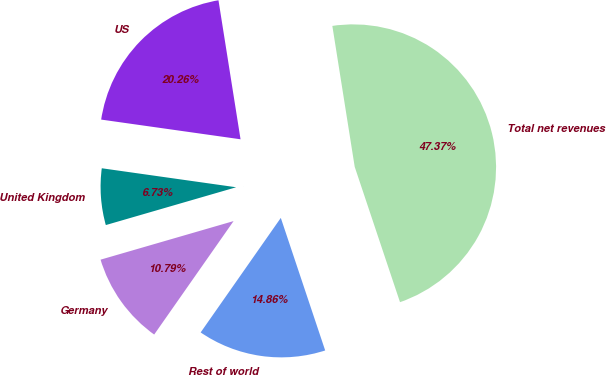<chart> <loc_0><loc_0><loc_500><loc_500><pie_chart><fcel>US<fcel>United Kingdom<fcel>Germany<fcel>Rest of world<fcel>Total net revenues<nl><fcel>20.26%<fcel>6.73%<fcel>10.79%<fcel>14.86%<fcel>47.37%<nl></chart> 